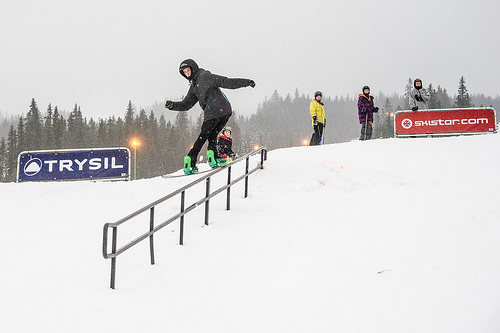Are there both a bicycle and a snowboard in the picture? No, there is no bicycle in the picture, but a person is riding a snowboard. 